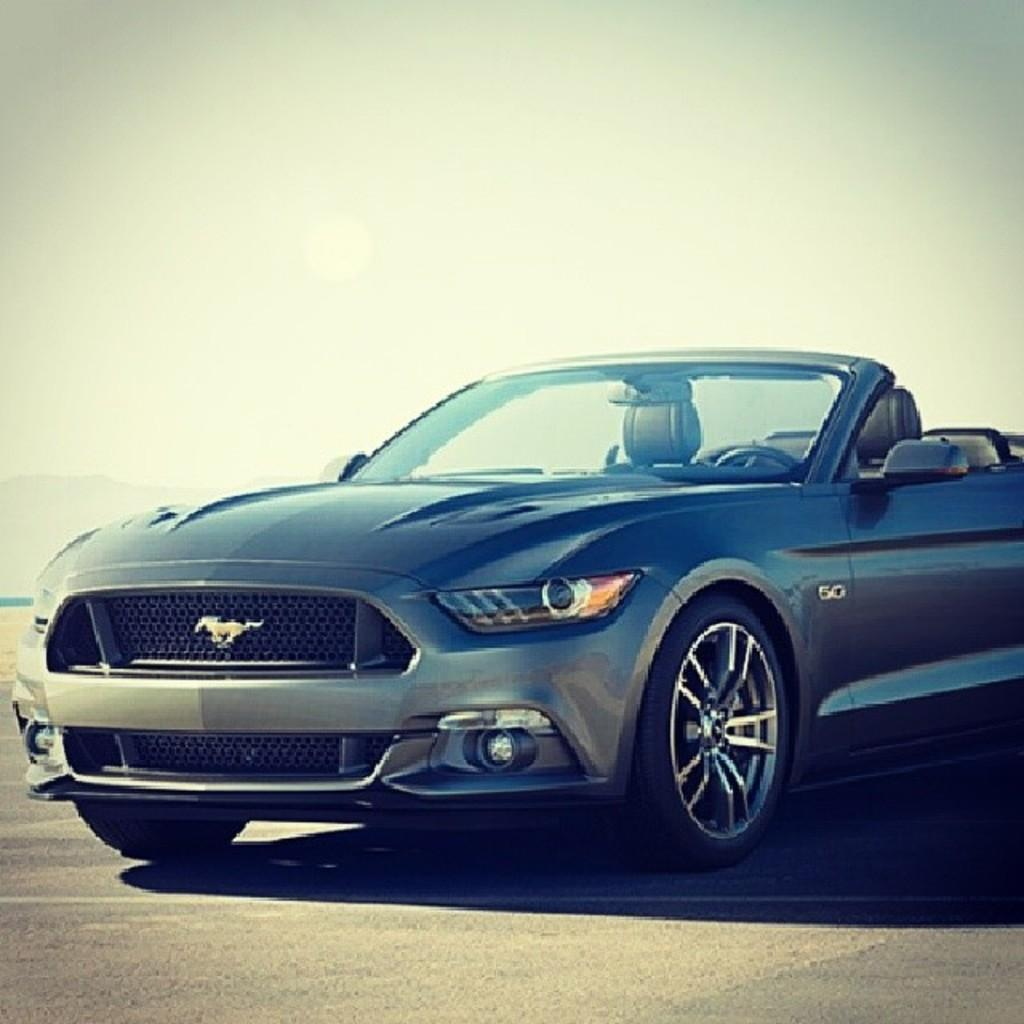What is the main subject of the image? The main subject of the image is a car. Where is the car located in the image? The car is placed on the road. What type of kettle can be seen in the image? There is no kettle present in the image; it features a car on the road. Is the orange visible in the image? There is no mention of an orange in the provided facts, so it cannot be determined if an orange is present in the image. 